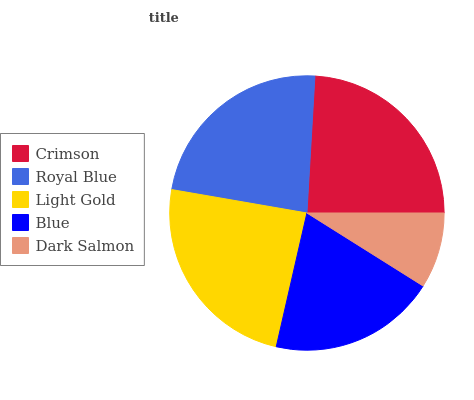Is Dark Salmon the minimum?
Answer yes or no. Yes. Is Light Gold the maximum?
Answer yes or no. Yes. Is Royal Blue the minimum?
Answer yes or no. No. Is Royal Blue the maximum?
Answer yes or no. No. Is Crimson greater than Royal Blue?
Answer yes or no. Yes. Is Royal Blue less than Crimson?
Answer yes or no. Yes. Is Royal Blue greater than Crimson?
Answer yes or no. No. Is Crimson less than Royal Blue?
Answer yes or no. No. Is Royal Blue the high median?
Answer yes or no. Yes. Is Royal Blue the low median?
Answer yes or no. Yes. Is Blue the high median?
Answer yes or no. No. Is Crimson the low median?
Answer yes or no. No. 